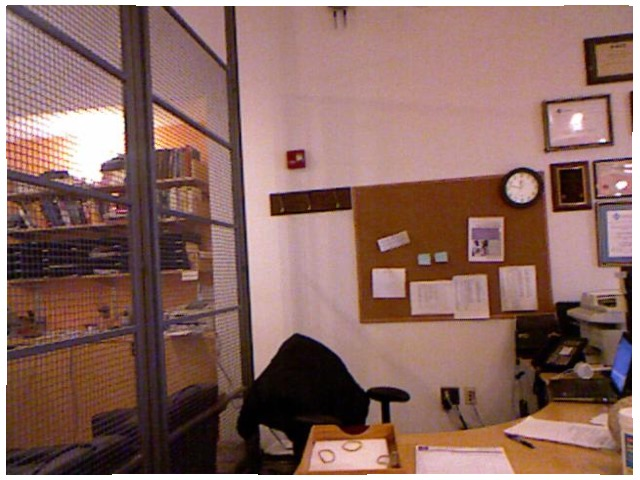<image>
Is the clock on the board? Yes. Looking at the image, I can see the clock is positioned on top of the board, with the board providing support. 